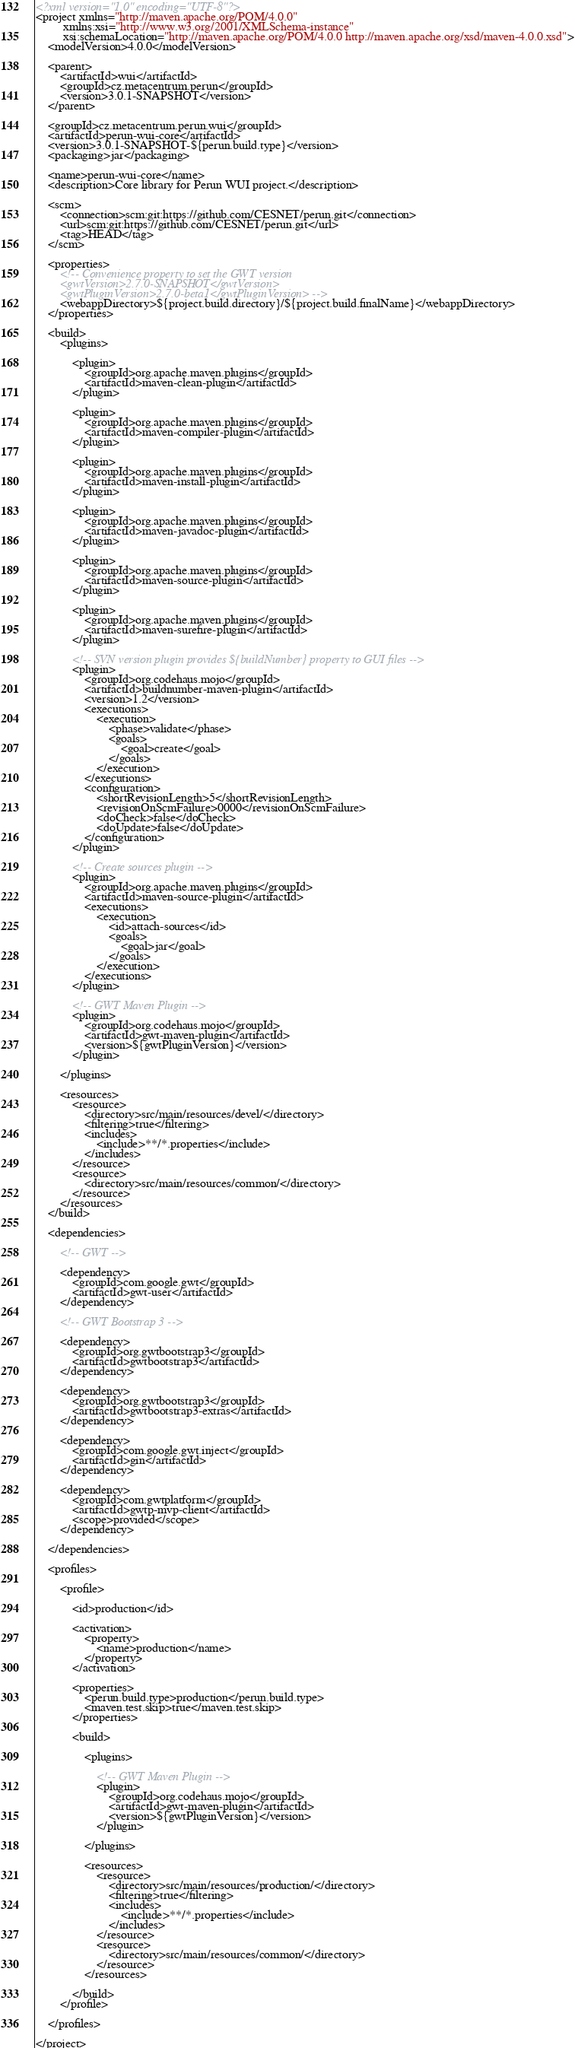<code> <loc_0><loc_0><loc_500><loc_500><_XML_><?xml version="1.0" encoding="UTF-8"?>
<project xmlns="http://maven.apache.org/POM/4.0.0"
         xmlns:xsi="http://www.w3.org/2001/XMLSchema-instance"
         xsi:schemaLocation="http://maven.apache.org/POM/4.0.0 http://maven.apache.org/xsd/maven-4.0.0.xsd">
    <modelVersion>4.0.0</modelVersion>

    <parent>
        <artifactId>wui</artifactId>
        <groupId>cz.metacentrum.perun</groupId>
        <version>3.0.1-SNAPSHOT</version>
    </parent>

    <groupId>cz.metacentrum.perun.wui</groupId>
    <artifactId>perun-wui-core</artifactId>
    <version>3.0.1-SNAPSHOT-${perun.build.type}</version>
    <packaging>jar</packaging>

    <name>perun-wui-core</name>
    <description>Core library for Perun WUI project.</description>

    <scm>
        <connection>scm:git:https://github.com/CESNET/perun.git</connection>
        <url>scm:git:https://github.com/CESNET/perun.git</url>
        <tag>HEAD</tag>
    </scm>

    <properties>
        <!-- Convenience property to set the GWT version
        <gwtVersion>2.7.0-SNAPSHOT</gwtVersion>
        <gwtPluginVersion>2.7.0-beta1</gwtPluginVersion> -->
        <webappDirectory>${project.build.directory}/${project.build.finalName}</webappDirectory>
    </properties>

    <build>
        <plugins>

            <plugin>
                <groupId>org.apache.maven.plugins</groupId>
                <artifactId>maven-clean-plugin</artifactId>
            </plugin>

            <plugin>
                <groupId>org.apache.maven.plugins</groupId>
                <artifactId>maven-compiler-plugin</artifactId>
            </plugin>

            <plugin>
                <groupId>org.apache.maven.plugins</groupId>
                <artifactId>maven-install-plugin</artifactId>
            </plugin>

            <plugin>
                <groupId>org.apache.maven.plugins</groupId>
                <artifactId>maven-javadoc-plugin</artifactId>
            </plugin>

            <plugin>
                <groupId>org.apache.maven.plugins</groupId>
                <artifactId>maven-source-plugin</artifactId>
            </plugin>

            <plugin>
                <groupId>org.apache.maven.plugins</groupId>
                <artifactId>maven-surefire-plugin</artifactId>
            </plugin>

            <!-- SVN version plugin provides ${buildNumber} property to GUI files -->
            <plugin>
                <groupId>org.codehaus.mojo</groupId>
                <artifactId>buildnumber-maven-plugin</artifactId>
                <version>1.2</version>
                <executions>
                    <execution>
                        <phase>validate</phase>
                        <goals>
                            <goal>create</goal>
                        </goals>
                    </execution>
                </executions>
                <configuration>
                    <shortRevisionLength>5</shortRevisionLength>
                    <revisionOnScmFailure>0000</revisionOnScmFailure>
                    <doCheck>false</doCheck>
                    <doUpdate>false</doUpdate>
                </configuration>
            </plugin>

            <!-- Create sources plugin -->
	        <plugin>
		        <groupId>org.apache.maven.plugins</groupId>
		        <artifactId>maven-source-plugin</artifactId>
		        <executions>
			        <execution>
				        <id>attach-sources</id>
				        <goals>
					        <goal>jar</goal>
				        </goals>
			        </execution>
		        </executions>
	        </plugin>

            <!-- GWT Maven Plugin -->
            <plugin>
                <groupId>org.codehaus.mojo</groupId>
                <artifactId>gwt-maven-plugin</artifactId>
                <version>${gwtPluginVersion}</version>
            </plugin>

        </plugins>

        <resources>
            <resource>
                <directory>src/main/resources/devel/</directory>
                <filtering>true</filtering>
                <includes>
                    <include>**/*.properties</include>
                </includes>
            </resource>
            <resource>
                <directory>src/main/resources/common/</directory>
            </resource>
        </resources>
    </build>

    <dependencies>

        <!-- GWT -->

        <dependency>
            <groupId>com.google.gwt</groupId>
            <artifactId>gwt-user</artifactId>
        </dependency>

	    <!-- GWT Bootstrap 3 -->

	    <dependency>
		    <groupId>org.gwtbootstrap3</groupId>
		    <artifactId>gwtbootstrap3</artifactId>
	    </dependency>

	    <dependency>
		    <groupId>org.gwtbootstrap3</groupId>
		    <artifactId>gwtbootstrap3-extras</artifactId>
	    </dependency>

        <dependency>
            <groupId>com.google.gwt.inject</groupId>
            <artifactId>gin</artifactId>
        </dependency>

        <dependency>
            <groupId>com.gwtplatform</groupId>
            <artifactId>gwtp-mvp-client</artifactId>
            <scope>provided</scope>
        </dependency>

    </dependencies>

    <profiles>

        <profile>

            <id>production</id>

	        <activation>
		        <property>
			        <name>production</name>
		        </property>
	        </activation>

            <properties>
                <perun.build.type>production</perun.build.type>
                <maven.test.skip>true</maven.test.skip>
            </properties>

            <build>

                <plugins>

                    <!-- GWT Maven Plugin -->
                    <plugin>
                        <groupId>org.codehaus.mojo</groupId>
                        <artifactId>gwt-maven-plugin</artifactId>
                        <version>${gwtPluginVersion}</version>
                    </plugin>

                </plugins>

                <resources>
                    <resource>
                        <directory>src/main/resources/production/</directory>
                        <filtering>true</filtering>
                        <includes>
                            <include>**/*.properties</include>
                        </includes>
                    </resource>
                    <resource>
                        <directory>src/main/resources/common/</directory>
                    </resource>
                </resources>

            </build>
        </profile>

    </profiles>

</project>
</code> 